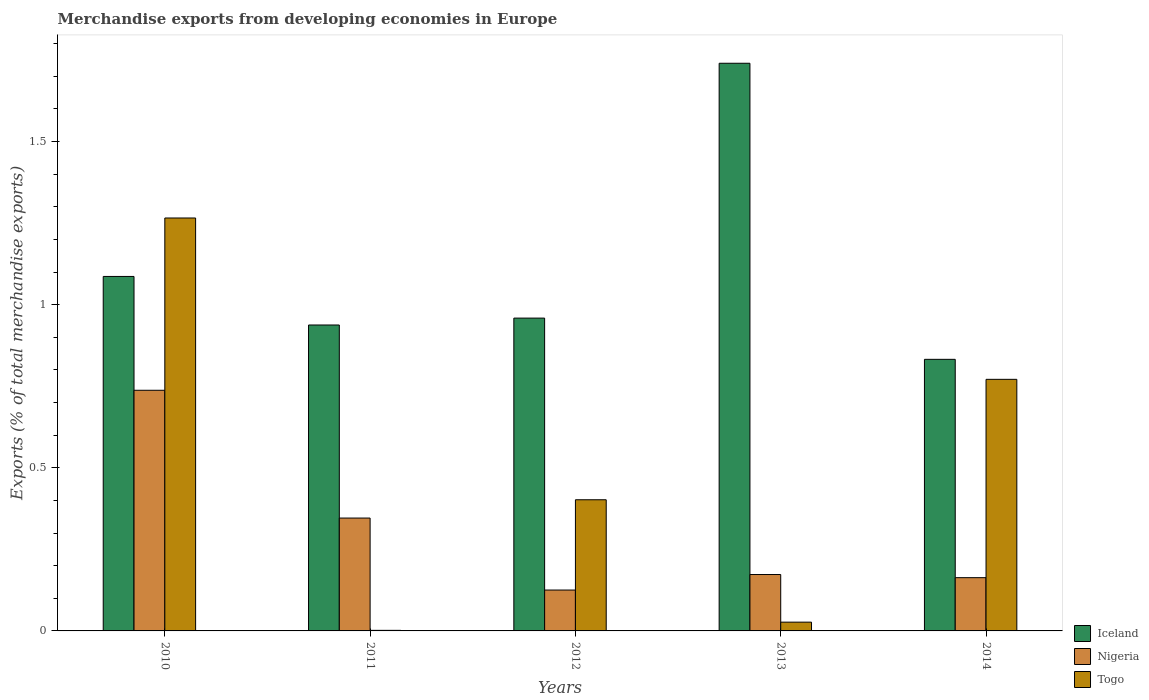How many groups of bars are there?
Give a very brief answer. 5. How many bars are there on the 2nd tick from the left?
Ensure brevity in your answer.  3. What is the percentage of total merchandise exports in Togo in 2014?
Your answer should be compact. 0.77. Across all years, what is the maximum percentage of total merchandise exports in Togo?
Your response must be concise. 1.27. Across all years, what is the minimum percentage of total merchandise exports in Iceland?
Offer a very short reply. 0.83. In which year was the percentage of total merchandise exports in Iceland maximum?
Offer a terse response. 2013. What is the total percentage of total merchandise exports in Nigeria in the graph?
Keep it short and to the point. 1.54. What is the difference between the percentage of total merchandise exports in Iceland in 2010 and that in 2013?
Ensure brevity in your answer.  -0.65. What is the difference between the percentage of total merchandise exports in Nigeria in 2011 and the percentage of total merchandise exports in Iceland in 2013?
Ensure brevity in your answer.  -1.39. What is the average percentage of total merchandise exports in Togo per year?
Your answer should be compact. 0.49. In the year 2014, what is the difference between the percentage of total merchandise exports in Togo and percentage of total merchandise exports in Nigeria?
Your answer should be very brief. 0.61. In how many years, is the percentage of total merchandise exports in Nigeria greater than 0.4 %?
Provide a short and direct response. 1. What is the ratio of the percentage of total merchandise exports in Iceland in 2010 to that in 2011?
Provide a short and direct response. 1.16. Is the percentage of total merchandise exports in Nigeria in 2013 less than that in 2014?
Make the answer very short. No. What is the difference between the highest and the second highest percentage of total merchandise exports in Iceland?
Offer a very short reply. 0.65. What is the difference between the highest and the lowest percentage of total merchandise exports in Iceland?
Provide a short and direct response. 0.91. In how many years, is the percentage of total merchandise exports in Nigeria greater than the average percentage of total merchandise exports in Nigeria taken over all years?
Provide a succinct answer. 2. What does the 1st bar from the left in 2012 represents?
Offer a terse response. Iceland. What does the 1st bar from the right in 2012 represents?
Offer a very short reply. Togo. Is it the case that in every year, the sum of the percentage of total merchandise exports in Iceland and percentage of total merchandise exports in Nigeria is greater than the percentage of total merchandise exports in Togo?
Ensure brevity in your answer.  Yes. How many years are there in the graph?
Offer a very short reply. 5. Are the values on the major ticks of Y-axis written in scientific E-notation?
Keep it short and to the point. No. Does the graph contain any zero values?
Make the answer very short. No. Where does the legend appear in the graph?
Your response must be concise. Bottom right. What is the title of the graph?
Your response must be concise. Merchandise exports from developing economies in Europe. What is the label or title of the X-axis?
Your answer should be very brief. Years. What is the label or title of the Y-axis?
Your answer should be compact. Exports (% of total merchandise exports). What is the Exports (% of total merchandise exports) of Iceland in 2010?
Ensure brevity in your answer.  1.09. What is the Exports (% of total merchandise exports) in Nigeria in 2010?
Keep it short and to the point. 0.74. What is the Exports (% of total merchandise exports) in Togo in 2010?
Ensure brevity in your answer.  1.27. What is the Exports (% of total merchandise exports) of Iceland in 2011?
Your answer should be very brief. 0.94. What is the Exports (% of total merchandise exports) in Nigeria in 2011?
Offer a very short reply. 0.35. What is the Exports (% of total merchandise exports) of Togo in 2011?
Your answer should be very brief. 0. What is the Exports (% of total merchandise exports) of Iceland in 2012?
Your response must be concise. 0.96. What is the Exports (% of total merchandise exports) of Nigeria in 2012?
Make the answer very short. 0.13. What is the Exports (% of total merchandise exports) of Togo in 2012?
Offer a very short reply. 0.4. What is the Exports (% of total merchandise exports) of Iceland in 2013?
Your answer should be very brief. 1.74. What is the Exports (% of total merchandise exports) in Nigeria in 2013?
Your answer should be compact. 0.17. What is the Exports (% of total merchandise exports) of Togo in 2013?
Make the answer very short. 0.03. What is the Exports (% of total merchandise exports) in Iceland in 2014?
Offer a terse response. 0.83. What is the Exports (% of total merchandise exports) in Nigeria in 2014?
Provide a short and direct response. 0.16. What is the Exports (% of total merchandise exports) of Togo in 2014?
Make the answer very short. 0.77. Across all years, what is the maximum Exports (% of total merchandise exports) of Iceland?
Ensure brevity in your answer.  1.74. Across all years, what is the maximum Exports (% of total merchandise exports) of Nigeria?
Offer a very short reply. 0.74. Across all years, what is the maximum Exports (% of total merchandise exports) in Togo?
Provide a succinct answer. 1.27. Across all years, what is the minimum Exports (% of total merchandise exports) in Iceland?
Give a very brief answer. 0.83. Across all years, what is the minimum Exports (% of total merchandise exports) of Nigeria?
Offer a very short reply. 0.13. Across all years, what is the minimum Exports (% of total merchandise exports) of Togo?
Give a very brief answer. 0. What is the total Exports (% of total merchandise exports) of Iceland in the graph?
Keep it short and to the point. 5.56. What is the total Exports (% of total merchandise exports) of Nigeria in the graph?
Make the answer very short. 1.54. What is the total Exports (% of total merchandise exports) of Togo in the graph?
Your answer should be very brief. 2.47. What is the difference between the Exports (% of total merchandise exports) in Iceland in 2010 and that in 2011?
Your response must be concise. 0.15. What is the difference between the Exports (% of total merchandise exports) of Nigeria in 2010 and that in 2011?
Provide a succinct answer. 0.39. What is the difference between the Exports (% of total merchandise exports) of Togo in 2010 and that in 2011?
Offer a very short reply. 1.26. What is the difference between the Exports (% of total merchandise exports) in Iceland in 2010 and that in 2012?
Keep it short and to the point. 0.13. What is the difference between the Exports (% of total merchandise exports) of Nigeria in 2010 and that in 2012?
Provide a short and direct response. 0.61. What is the difference between the Exports (% of total merchandise exports) of Togo in 2010 and that in 2012?
Ensure brevity in your answer.  0.86. What is the difference between the Exports (% of total merchandise exports) of Iceland in 2010 and that in 2013?
Provide a succinct answer. -0.65. What is the difference between the Exports (% of total merchandise exports) of Nigeria in 2010 and that in 2013?
Your answer should be compact. 0.56. What is the difference between the Exports (% of total merchandise exports) of Togo in 2010 and that in 2013?
Offer a very short reply. 1.24. What is the difference between the Exports (% of total merchandise exports) in Iceland in 2010 and that in 2014?
Offer a terse response. 0.25. What is the difference between the Exports (% of total merchandise exports) of Nigeria in 2010 and that in 2014?
Offer a very short reply. 0.57. What is the difference between the Exports (% of total merchandise exports) of Togo in 2010 and that in 2014?
Your answer should be very brief. 0.49. What is the difference between the Exports (% of total merchandise exports) of Iceland in 2011 and that in 2012?
Keep it short and to the point. -0.02. What is the difference between the Exports (% of total merchandise exports) of Nigeria in 2011 and that in 2012?
Make the answer very short. 0.22. What is the difference between the Exports (% of total merchandise exports) of Togo in 2011 and that in 2012?
Ensure brevity in your answer.  -0.4. What is the difference between the Exports (% of total merchandise exports) in Iceland in 2011 and that in 2013?
Your response must be concise. -0.8. What is the difference between the Exports (% of total merchandise exports) of Nigeria in 2011 and that in 2013?
Provide a succinct answer. 0.17. What is the difference between the Exports (% of total merchandise exports) in Togo in 2011 and that in 2013?
Keep it short and to the point. -0.03. What is the difference between the Exports (% of total merchandise exports) in Iceland in 2011 and that in 2014?
Offer a very short reply. 0.11. What is the difference between the Exports (% of total merchandise exports) in Nigeria in 2011 and that in 2014?
Provide a short and direct response. 0.18. What is the difference between the Exports (% of total merchandise exports) in Togo in 2011 and that in 2014?
Your answer should be compact. -0.77. What is the difference between the Exports (% of total merchandise exports) in Iceland in 2012 and that in 2013?
Provide a short and direct response. -0.78. What is the difference between the Exports (% of total merchandise exports) of Nigeria in 2012 and that in 2013?
Ensure brevity in your answer.  -0.05. What is the difference between the Exports (% of total merchandise exports) of Togo in 2012 and that in 2013?
Give a very brief answer. 0.38. What is the difference between the Exports (% of total merchandise exports) in Iceland in 2012 and that in 2014?
Provide a short and direct response. 0.13. What is the difference between the Exports (% of total merchandise exports) in Nigeria in 2012 and that in 2014?
Give a very brief answer. -0.04. What is the difference between the Exports (% of total merchandise exports) of Togo in 2012 and that in 2014?
Make the answer very short. -0.37. What is the difference between the Exports (% of total merchandise exports) of Iceland in 2013 and that in 2014?
Offer a terse response. 0.91. What is the difference between the Exports (% of total merchandise exports) of Nigeria in 2013 and that in 2014?
Make the answer very short. 0.01. What is the difference between the Exports (% of total merchandise exports) of Togo in 2013 and that in 2014?
Keep it short and to the point. -0.74. What is the difference between the Exports (% of total merchandise exports) of Iceland in 2010 and the Exports (% of total merchandise exports) of Nigeria in 2011?
Make the answer very short. 0.74. What is the difference between the Exports (% of total merchandise exports) of Iceland in 2010 and the Exports (% of total merchandise exports) of Togo in 2011?
Offer a terse response. 1.08. What is the difference between the Exports (% of total merchandise exports) in Nigeria in 2010 and the Exports (% of total merchandise exports) in Togo in 2011?
Keep it short and to the point. 0.74. What is the difference between the Exports (% of total merchandise exports) in Iceland in 2010 and the Exports (% of total merchandise exports) in Nigeria in 2012?
Provide a short and direct response. 0.96. What is the difference between the Exports (% of total merchandise exports) in Iceland in 2010 and the Exports (% of total merchandise exports) in Togo in 2012?
Your response must be concise. 0.68. What is the difference between the Exports (% of total merchandise exports) in Nigeria in 2010 and the Exports (% of total merchandise exports) in Togo in 2012?
Make the answer very short. 0.34. What is the difference between the Exports (% of total merchandise exports) in Iceland in 2010 and the Exports (% of total merchandise exports) in Nigeria in 2013?
Keep it short and to the point. 0.91. What is the difference between the Exports (% of total merchandise exports) in Iceland in 2010 and the Exports (% of total merchandise exports) in Togo in 2013?
Your answer should be very brief. 1.06. What is the difference between the Exports (% of total merchandise exports) in Nigeria in 2010 and the Exports (% of total merchandise exports) in Togo in 2013?
Keep it short and to the point. 0.71. What is the difference between the Exports (% of total merchandise exports) in Iceland in 2010 and the Exports (% of total merchandise exports) in Nigeria in 2014?
Keep it short and to the point. 0.92. What is the difference between the Exports (% of total merchandise exports) of Iceland in 2010 and the Exports (% of total merchandise exports) of Togo in 2014?
Offer a terse response. 0.32. What is the difference between the Exports (% of total merchandise exports) in Nigeria in 2010 and the Exports (% of total merchandise exports) in Togo in 2014?
Your response must be concise. -0.03. What is the difference between the Exports (% of total merchandise exports) of Iceland in 2011 and the Exports (% of total merchandise exports) of Nigeria in 2012?
Provide a succinct answer. 0.81. What is the difference between the Exports (% of total merchandise exports) in Iceland in 2011 and the Exports (% of total merchandise exports) in Togo in 2012?
Make the answer very short. 0.54. What is the difference between the Exports (% of total merchandise exports) in Nigeria in 2011 and the Exports (% of total merchandise exports) in Togo in 2012?
Provide a succinct answer. -0.06. What is the difference between the Exports (% of total merchandise exports) in Iceland in 2011 and the Exports (% of total merchandise exports) in Nigeria in 2013?
Provide a short and direct response. 0.76. What is the difference between the Exports (% of total merchandise exports) of Iceland in 2011 and the Exports (% of total merchandise exports) of Togo in 2013?
Offer a terse response. 0.91. What is the difference between the Exports (% of total merchandise exports) in Nigeria in 2011 and the Exports (% of total merchandise exports) in Togo in 2013?
Offer a terse response. 0.32. What is the difference between the Exports (% of total merchandise exports) of Iceland in 2011 and the Exports (% of total merchandise exports) of Nigeria in 2014?
Provide a succinct answer. 0.77. What is the difference between the Exports (% of total merchandise exports) of Iceland in 2011 and the Exports (% of total merchandise exports) of Togo in 2014?
Your answer should be compact. 0.17. What is the difference between the Exports (% of total merchandise exports) of Nigeria in 2011 and the Exports (% of total merchandise exports) of Togo in 2014?
Offer a terse response. -0.43. What is the difference between the Exports (% of total merchandise exports) of Iceland in 2012 and the Exports (% of total merchandise exports) of Nigeria in 2013?
Offer a terse response. 0.79. What is the difference between the Exports (% of total merchandise exports) in Iceland in 2012 and the Exports (% of total merchandise exports) in Togo in 2013?
Give a very brief answer. 0.93. What is the difference between the Exports (% of total merchandise exports) of Nigeria in 2012 and the Exports (% of total merchandise exports) of Togo in 2013?
Your answer should be very brief. 0.1. What is the difference between the Exports (% of total merchandise exports) in Iceland in 2012 and the Exports (% of total merchandise exports) in Nigeria in 2014?
Make the answer very short. 0.8. What is the difference between the Exports (% of total merchandise exports) of Iceland in 2012 and the Exports (% of total merchandise exports) of Togo in 2014?
Your answer should be very brief. 0.19. What is the difference between the Exports (% of total merchandise exports) in Nigeria in 2012 and the Exports (% of total merchandise exports) in Togo in 2014?
Your answer should be compact. -0.65. What is the difference between the Exports (% of total merchandise exports) of Iceland in 2013 and the Exports (% of total merchandise exports) of Nigeria in 2014?
Give a very brief answer. 1.58. What is the difference between the Exports (% of total merchandise exports) of Iceland in 2013 and the Exports (% of total merchandise exports) of Togo in 2014?
Ensure brevity in your answer.  0.97. What is the difference between the Exports (% of total merchandise exports) of Nigeria in 2013 and the Exports (% of total merchandise exports) of Togo in 2014?
Keep it short and to the point. -0.6. What is the average Exports (% of total merchandise exports) of Iceland per year?
Your response must be concise. 1.11. What is the average Exports (% of total merchandise exports) of Nigeria per year?
Provide a succinct answer. 0.31. What is the average Exports (% of total merchandise exports) of Togo per year?
Ensure brevity in your answer.  0.49. In the year 2010, what is the difference between the Exports (% of total merchandise exports) of Iceland and Exports (% of total merchandise exports) of Nigeria?
Offer a terse response. 0.35. In the year 2010, what is the difference between the Exports (% of total merchandise exports) of Iceland and Exports (% of total merchandise exports) of Togo?
Keep it short and to the point. -0.18. In the year 2010, what is the difference between the Exports (% of total merchandise exports) in Nigeria and Exports (% of total merchandise exports) in Togo?
Offer a very short reply. -0.53. In the year 2011, what is the difference between the Exports (% of total merchandise exports) in Iceland and Exports (% of total merchandise exports) in Nigeria?
Offer a terse response. 0.59. In the year 2011, what is the difference between the Exports (% of total merchandise exports) in Iceland and Exports (% of total merchandise exports) in Togo?
Offer a very short reply. 0.94. In the year 2011, what is the difference between the Exports (% of total merchandise exports) in Nigeria and Exports (% of total merchandise exports) in Togo?
Give a very brief answer. 0.34. In the year 2012, what is the difference between the Exports (% of total merchandise exports) of Iceland and Exports (% of total merchandise exports) of Nigeria?
Provide a succinct answer. 0.83. In the year 2012, what is the difference between the Exports (% of total merchandise exports) of Iceland and Exports (% of total merchandise exports) of Togo?
Provide a succinct answer. 0.56. In the year 2012, what is the difference between the Exports (% of total merchandise exports) in Nigeria and Exports (% of total merchandise exports) in Togo?
Offer a very short reply. -0.28. In the year 2013, what is the difference between the Exports (% of total merchandise exports) in Iceland and Exports (% of total merchandise exports) in Nigeria?
Offer a terse response. 1.57. In the year 2013, what is the difference between the Exports (% of total merchandise exports) of Iceland and Exports (% of total merchandise exports) of Togo?
Offer a very short reply. 1.71. In the year 2013, what is the difference between the Exports (% of total merchandise exports) in Nigeria and Exports (% of total merchandise exports) in Togo?
Offer a terse response. 0.15. In the year 2014, what is the difference between the Exports (% of total merchandise exports) in Iceland and Exports (% of total merchandise exports) in Nigeria?
Keep it short and to the point. 0.67. In the year 2014, what is the difference between the Exports (% of total merchandise exports) in Iceland and Exports (% of total merchandise exports) in Togo?
Your response must be concise. 0.06. In the year 2014, what is the difference between the Exports (% of total merchandise exports) of Nigeria and Exports (% of total merchandise exports) of Togo?
Offer a terse response. -0.61. What is the ratio of the Exports (% of total merchandise exports) in Iceland in 2010 to that in 2011?
Make the answer very short. 1.16. What is the ratio of the Exports (% of total merchandise exports) of Nigeria in 2010 to that in 2011?
Offer a very short reply. 2.13. What is the ratio of the Exports (% of total merchandise exports) in Togo in 2010 to that in 2011?
Give a very brief answer. 728.76. What is the ratio of the Exports (% of total merchandise exports) in Iceland in 2010 to that in 2012?
Offer a very short reply. 1.13. What is the ratio of the Exports (% of total merchandise exports) of Nigeria in 2010 to that in 2012?
Give a very brief answer. 5.89. What is the ratio of the Exports (% of total merchandise exports) in Togo in 2010 to that in 2012?
Your response must be concise. 3.15. What is the ratio of the Exports (% of total merchandise exports) in Iceland in 2010 to that in 2013?
Your answer should be compact. 0.62. What is the ratio of the Exports (% of total merchandise exports) of Nigeria in 2010 to that in 2013?
Provide a succinct answer. 4.27. What is the ratio of the Exports (% of total merchandise exports) in Togo in 2010 to that in 2013?
Keep it short and to the point. 47.07. What is the ratio of the Exports (% of total merchandise exports) of Iceland in 2010 to that in 2014?
Your response must be concise. 1.31. What is the ratio of the Exports (% of total merchandise exports) of Nigeria in 2010 to that in 2014?
Make the answer very short. 4.52. What is the ratio of the Exports (% of total merchandise exports) in Togo in 2010 to that in 2014?
Offer a very short reply. 1.64. What is the ratio of the Exports (% of total merchandise exports) in Iceland in 2011 to that in 2012?
Make the answer very short. 0.98. What is the ratio of the Exports (% of total merchandise exports) of Nigeria in 2011 to that in 2012?
Your answer should be very brief. 2.76. What is the ratio of the Exports (% of total merchandise exports) of Togo in 2011 to that in 2012?
Your answer should be compact. 0. What is the ratio of the Exports (% of total merchandise exports) in Iceland in 2011 to that in 2013?
Offer a terse response. 0.54. What is the ratio of the Exports (% of total merchandise exports) of Nigeria in 2011 to that in 2013?
Offer a terse response. 2. What is the ratio of the Exports (% of total merchandise exports) in Togo in 2011 to that in 2013?
Make the answer very short. 0.06. What is the ratio of the Exports (% of total merchandise exports) of Iceland in 2011 to that in 2014?
Make the answer very short. 1.13. What is the ratio of the Exports (% of total merchandise exports) of Nigeria in 2011 to that in 2014?
Your answer should be compact. 2.12. What is the ratio of the Exports (% of total merchandise exports) of Togo in 2011 to that in 2014?
Offer a very short reply. 0. What is the ratio of the Exports (% of total merchandise exports) in Iceland in 2012 to that in 2013?
Keep it short and to the point. 0.55. What is the ratio of the Exports (% of total merchandise exports) of Nigeria in 2012 to that in 2013?
Make the answer very short. 0.72. What is the ratio of the Exports (% of total merchandise exports) of Togo in 2012 to that in 2013?
Your response must be concise. 14.95. What is the ratio of the Exports (% of total merchandise exports) in Iceland in 2012 to that in 2014?
Offer a very short reply. 1.15. What is the ratio of the Exports (% of total merchandise exports) of Nigeria in 2012 to that in 2014?
Make the answer very short. 0.77. What is the ratio of the Exports (% of total merchandise exports) in Togo in 2012 to that in 2014?
Keep it short and to the point. 0.52. What is the ratio of the Exports (% of total merchandise exports) of Iceland in 2013 to that in 2014?
Provide a short and direct response. 2.09. What is the ratio of the Exports (% of total merchandise exports) of Nigeria in 2013 to that in 2014?
Your answer should be compact. 1.06. What is the ratio of the Exports (% of total merchandise exports) in Togo in 2013 to that in 2014?
Provide a succinct answer. 0.03. What is the difference between the highest and the second highest Exports (% of total merchandise exports) of Iceland?
Your answer should be compact. 0.65. What is the difference between the highest and the second highest Exports (% of total merchandise exports) in Nigeria?
Your answer should be compact. 0.39. What is the difference between the highest and the second highest Exports (% of total merchandise exports) in Togo?
Your answer should be very brief. 0.49. What is the difference between the highest and the lowest Exports (% of total merchandise exports) in Iceland?
Provide a short and direct response. 0.91. What is the difference between the highest and the lowest Exports (% of total merchandise exports) in Nigeria?
Make the answer very short. 0.61. What is the difference between the highest and the lowest Exports (% of total merchandise exports) of Togo?
Ensure brevity in your answer.  1.26. 